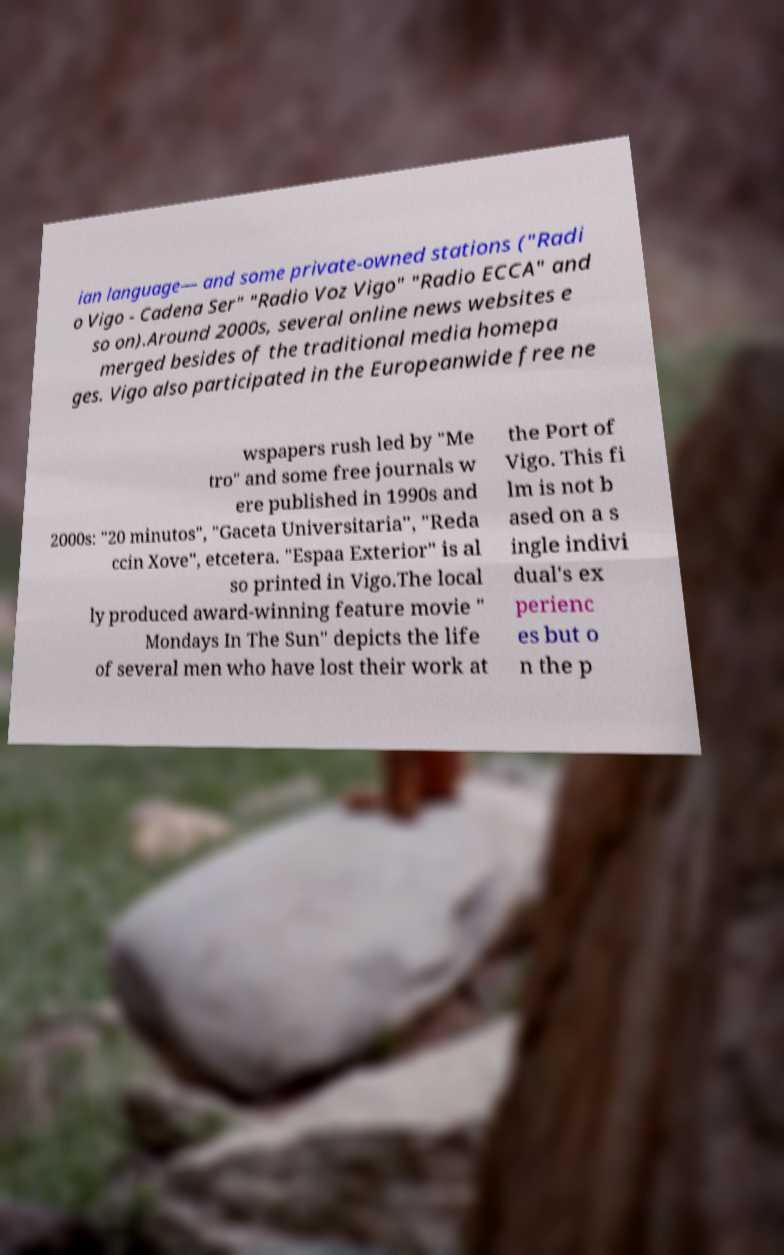Could you extract and type out the text from this image? ian language— and some private-owned stations ("Radi o Vigo - Cadena Ser" "Radio Voz Vigo" "Radio ECCA" and so on).Around 2000s, several online news websites e merged besides of the traditional media homepa ges. Vigo also participated in the Europeanwide free ne wspapers rush led by "Me tro" and some free journals w ere published in 1990s and 2000s: "20 minutos", "Gaceta Universitaria", "Reda ccin Xove", etcetera. "Espaa Exterior" is al so printed in Vigo.The local ly produced award-winning feature movie " Mondays In The Sun" depicts the life of several men who have lost their work at the Port of Vigo. This fi lm is not b ased on a s ingle indivi dual's ex perienc es but o n the p 